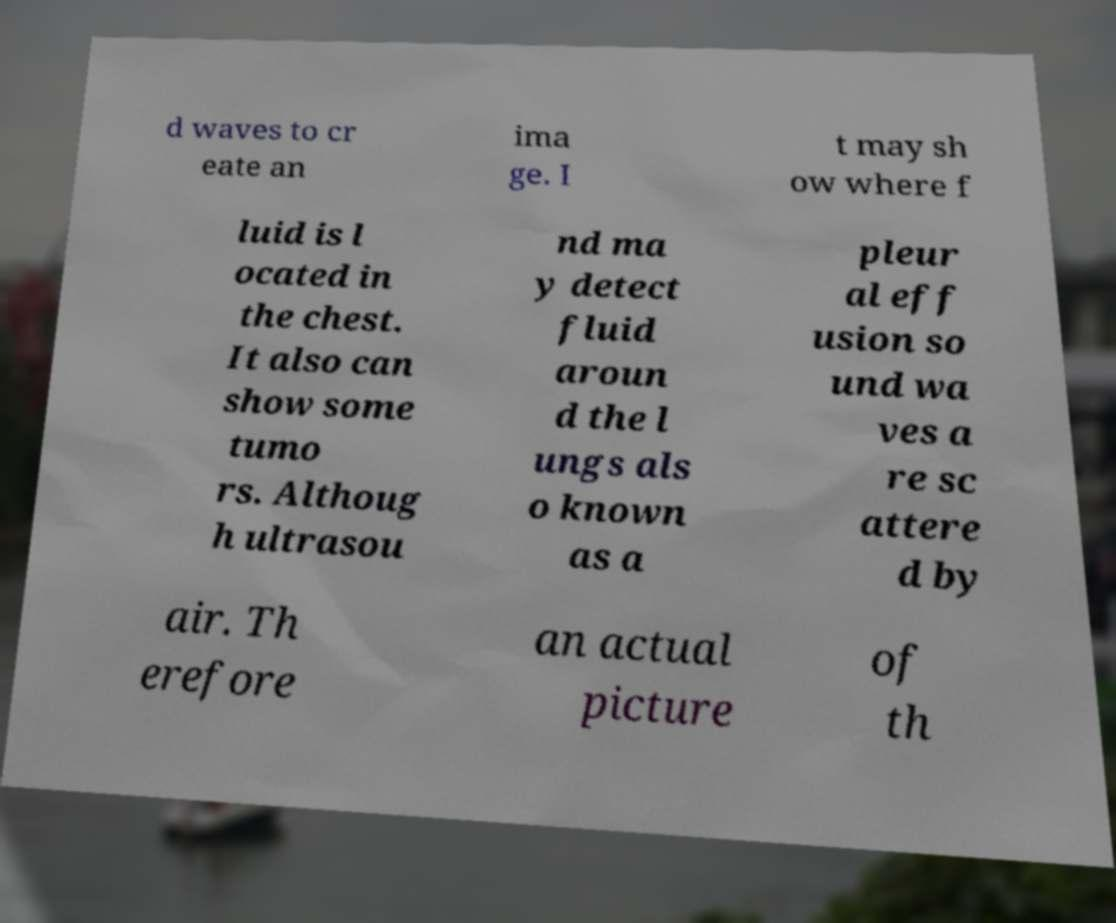Please identify and transcribe the text found in this image. d waves to cr eate an ima ge. I t may sh ow where f luid is l ocated in the chest. It also can show some tumo rs. Althoug h ultrasou nd ma y detect fluid aroun d the l ungs als o known as a pleur al eff usion so und wa ves a re sc attere d by air. Th erefore an actual picture of th 